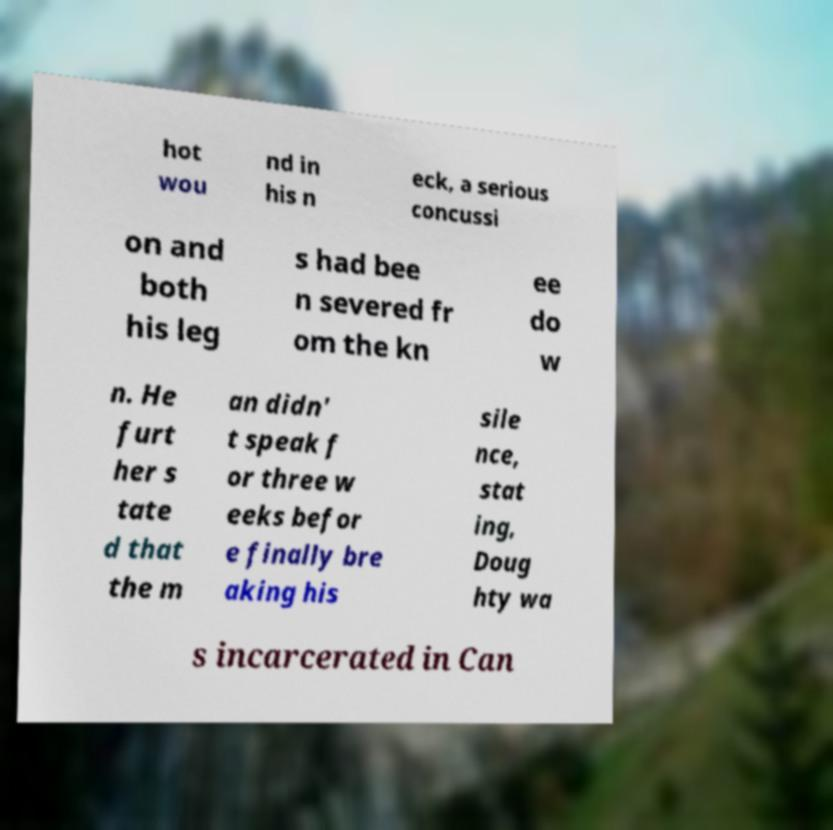Please identify and transcribe the text found in this image. hot wou nd in his n eck, a serious concussi on and both his leg s had bee n severed fr om the kn ee do w n. He furt her s tate d that the m an didn' t speak f or three w eeks befor e finally bre aking his sile nce, stat ing, Doug hty wa s incarcerated in Can 